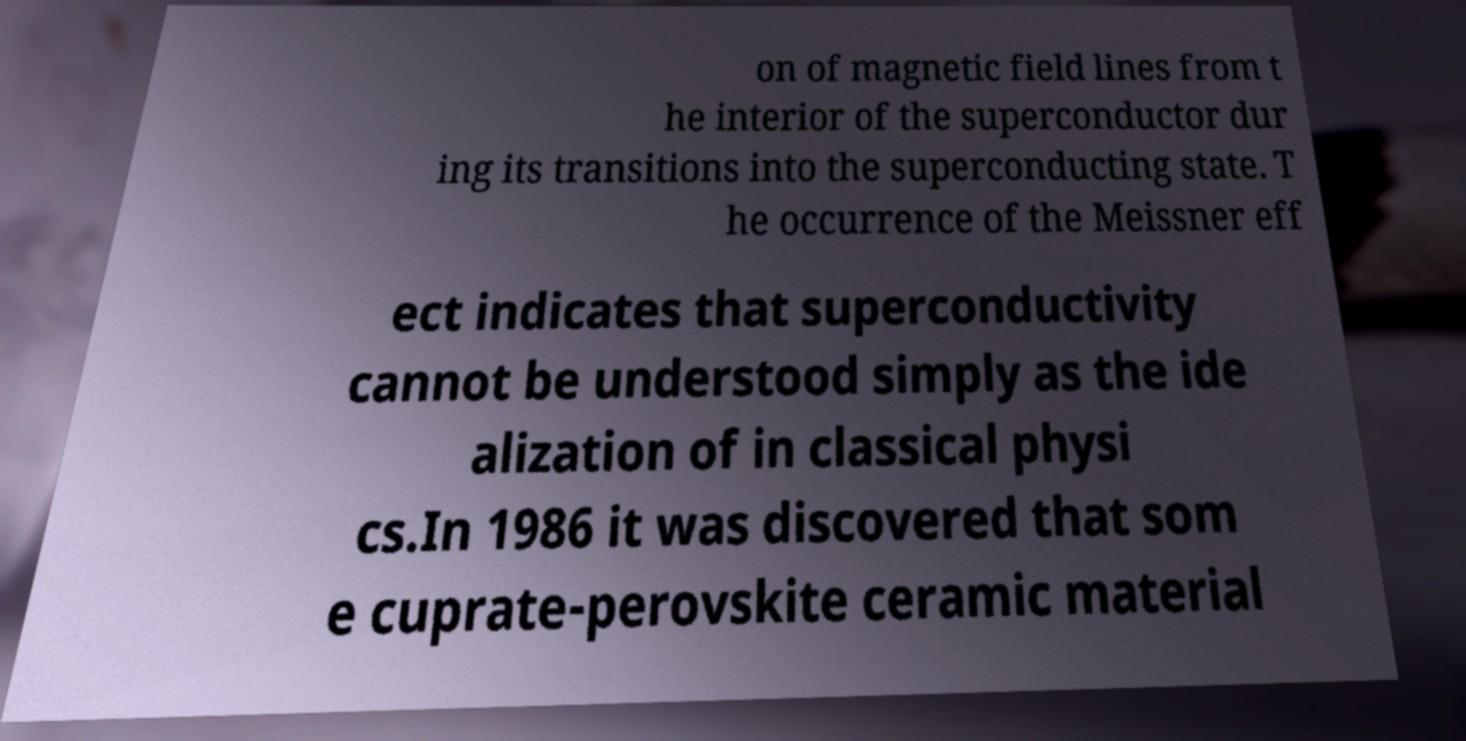For documentation purposes, I need the text within this image transcribed. Could you provide that? on of magnetic field lines from t he interior of the superconductor dur ing its transitions into the superconducting state. T he occurrence of the Meissner eff ect indicates that superconductivity cannot be understood simply as the ide alization of in classical physi cs.In 1986 it was discovered that som e cuprate-perovskite ceramic material 